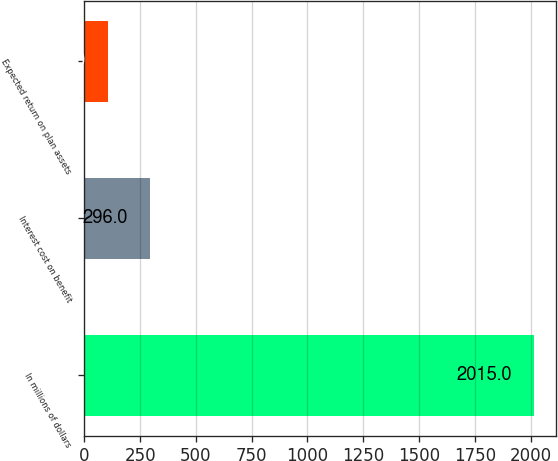Convert chart to OTSL. <chart><loc_0><loc_0><loc_500><loc_500><bar_chart><fcel>In millions of dollars<fcel>Interest cost on benefit<fcel>Expected return on plan assets<nl><fcel>2015<fcel>296<fcel>105<nl></chart> 